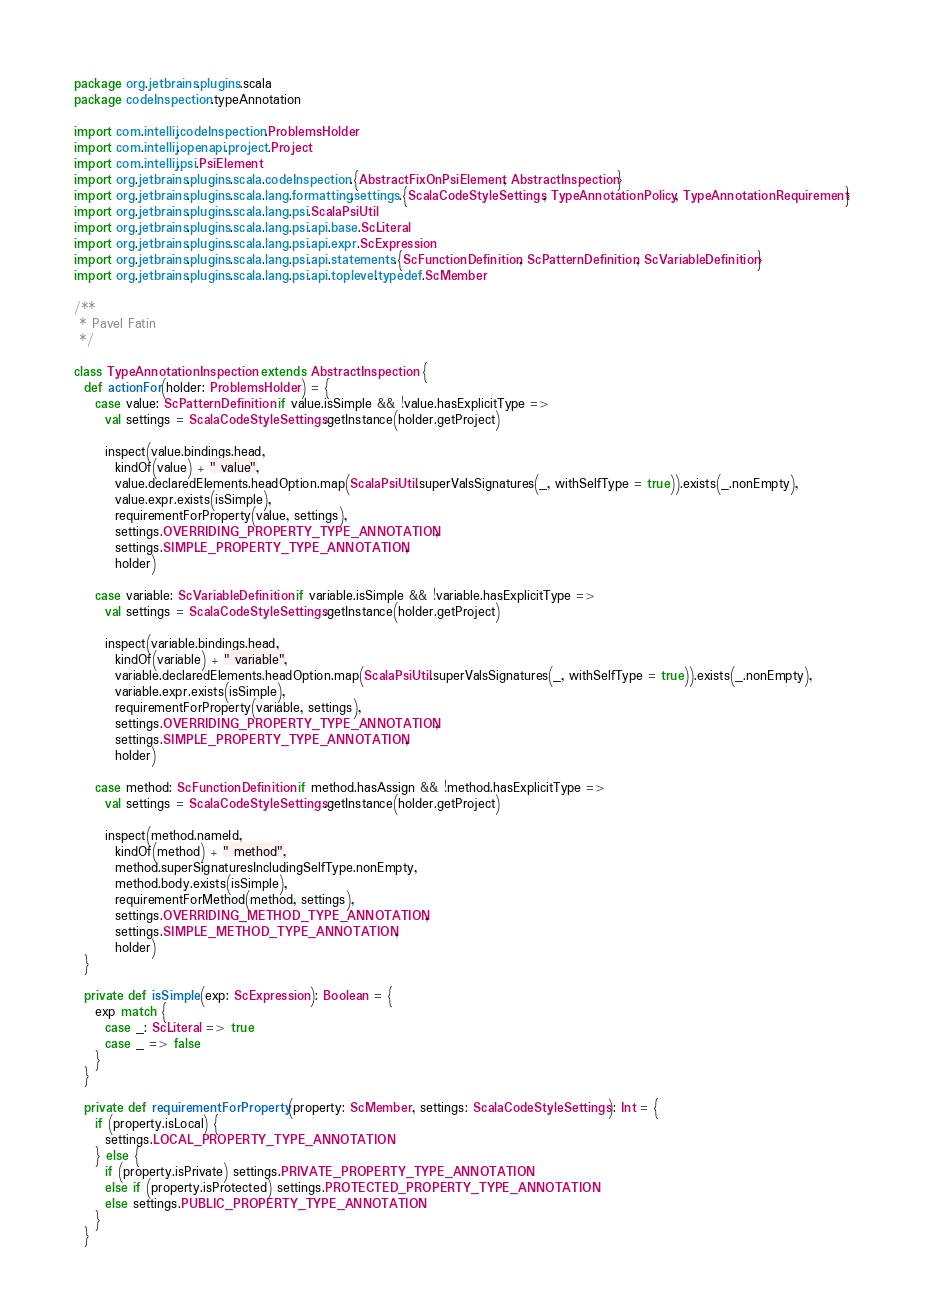<code> <loc_0><loc_0><loc_500><loc_500><_Scala_>package org.jetbrains.plugins.scala
package codeInspection.typeAnnotation

import com.intellij.codeInspection.ProblemsHolder
import com.intellij.openapi.project.Project
import com.intellij.psi.PsiElement
import org.jetbrains.plugins.scala.codeInspection.{AbstractFixOnPsiElement, AbstractInspection}
import org.jetbrains.plugins.scala.lang.formatting.settings.{ScalaCodeStyleSettings, TypeAnnotationPolicy, TypeAnnotationRequirement}
import org.jetbrains.plugins.scala.lang.psi.ScalaPsiUtil
import org.jetbrains.plugins.scala.lang.psi.api.base.ScLiteral
import org.jetbrains.plugins.scala.lang.psi.api.expr.ScExpression
import org.jetbrains.plugins.scala.lang.psi.api.statements.{ScFunctionDefinition, ScPatternDefinition, ScVariableDefinition}
import org.jetbrains.plugins.scala.lang.psi.api.toplevel.typedef.ScMember

/**
 * Pavel Fatin
 */

class TypeAnnotationInspection extends AbstractInspection {
  def actionFor(holder: ProblemsHolder) = {
    case value: ScPatternDefinition if value.isSimple && !value.hasExplicitType =>
      val settings = ScalaCodeStyleSettings.getInstance(holder.getProject)

      inspect(value.bindings.head,
        kindOf(value) + " value",
        value.declaredElements.headOption.map(ScalaPsiUtil.superValsSignatures(_, withSelfType = true)).exists(_.nonEmpty),
        value.expr.exists(isSimple),
        requirementForProperty(value, settings),
        settings.OVERRIDING_PROPERTY_TYPE_ANNOTATION,
        settings.SIMPLE_PROPERTY_TYPE_ANNOTATION,
        holder)

    case variable: ScVariableDefinition if variable.isSimple && !variable.hasExplicitType =>
      val settings = ScalaCodeStyleSettings.getInstance(holder.getProject)

      inspect(variable.bindings.head,
        kindOf(variable) + " variable",
        variable.declaredElements.headOption.map(ScalaPsiUtil.superValsSignatures(_, withSelfType = true)).exists(_.nonEmpty),
        variable.expr.exists(isSimple),
        requirementForProperty(variable, settings),
        settings.OVERRIDING_PROPERTY_TYPE_ANNOTATION,
        settings.SIMPLE_PROPERTY_TYPE_ANNOTATION,
        holder)

    case method: ScFunctionDefinition if method.hasAssign && !method.hasExplicitType =>
      val settings = ScalaCodeStyleSettings.getInstance(holder.getProject)

      inspect(method.nameId,
        kindOf(method) + " method",
        method.superSignaturesIncludingSelfType.nonEmpty,
        method.body.exists(isSimple),
        requirementForMethod(method, settings),
        settings.OVERRIDING_METHOD_TYPE_ANNOTATION,
        settings.SIMPLE_METHOD_TYPE_ANNOTATION,
        holder)
  }

  private def isSimple(exp: ScExpression): Boolean = {
    exp match {
      case _: ScLiteral => true
      case _ => false
    }
  }

  private def requirementForProperty(property: ScMember, settings: ScalaCodeStyleSettings): Int = {
    if (property.isLocal) {
      settings.LOCAL_PROPERTY_TYPE_ANNOTATION
    } else {
      if (property.isPrivate) settings.PRIVATE_PROPERTY_TYPE_ANNOTATION
      else if (property.isProtected) settings.PROTECTED_PROPERTY_TYPE_ANNOTATION
      else settings.PUBLIC_PROPERTY_TYPE_ANNOTATION
    }
  }
</code> 